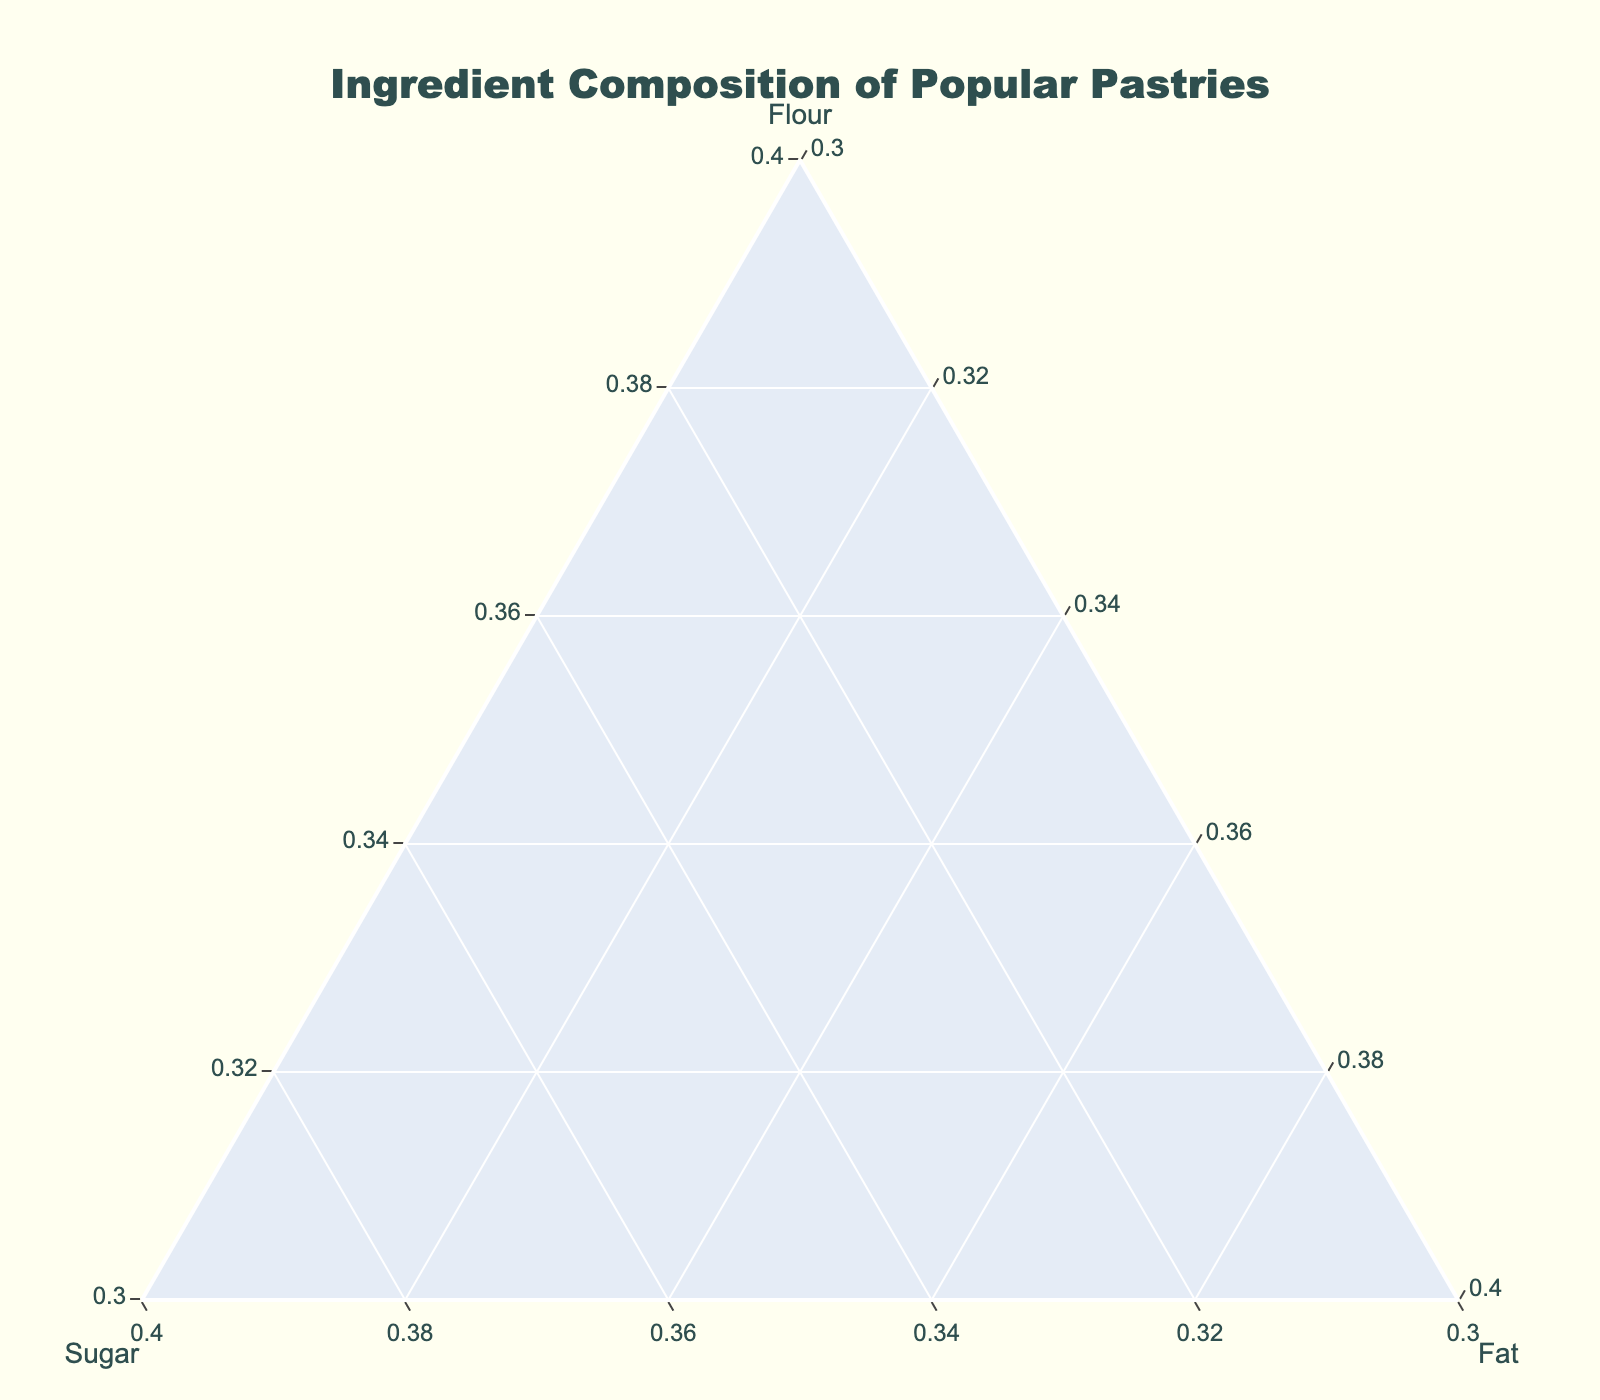What is the title of the figure? The title is located at the top of the figure and describes the main topic of the visualized data.
Answer: Ingredient Composition of Popular Pastries How many pastries are depicted in the figure? By counting the number of markers or labels in the ternary plot, we can determine the number of pastries.
Answer: 10 Which pastry has the highest percentage of sugar? Look for the point closest to the Sugar axis. The hover text or label will indicate which pastry this is.
Answer: Macaron How does the percentage of fat in a Croissant compare to that of a Brioche? Locate both pastries in the ternary plot, and compare their distances from the Fat axis. The hover text for each can give exact values.
Answer: Croissant has 40% fat, Brioche has 34% fat Which pastries are closest in ingredient composition? Observe which markers are nearest to each other in the ternary plot. These pastries share similar percentages of flour, sugar, and fat.
Answer: Danish and Brioche What is the combined percentage of sugar and fat in an Eclair? Find the Eclair point and sum up the sugar (25%) and fat (30%) percentages.
Answer: 55% Are any pastries evenly distributed in terms of ingredient composition? Look for points that are approximately equidistant from each axis, indicating balanced percentages of flour, sugar, and fat.
Answer: No, the compositions are mostly uneven Which pastry has the lowest sugar content, and how much is it? Identify the marker closest to the Flour and Fat axes. Check the hover text for the exact percentage.
Answer: Croissant, 5% sugar What is the relative position of the Cinnamon Roll compared to the Macaron in terms of sugar and flour? Examine both pastries on the ternary plot. Determine which one is closer to the Sugar and Flour axes to compare their percentages.
Answer: Cinnamon Roll has less sugar and more flour than Macaron Which pastries have a higher percentage of fat than flour? Look for markers closer to the Fat axis than the Flour axis. These pastries have a higher percentage of fat compared to flour.
Answer: None 